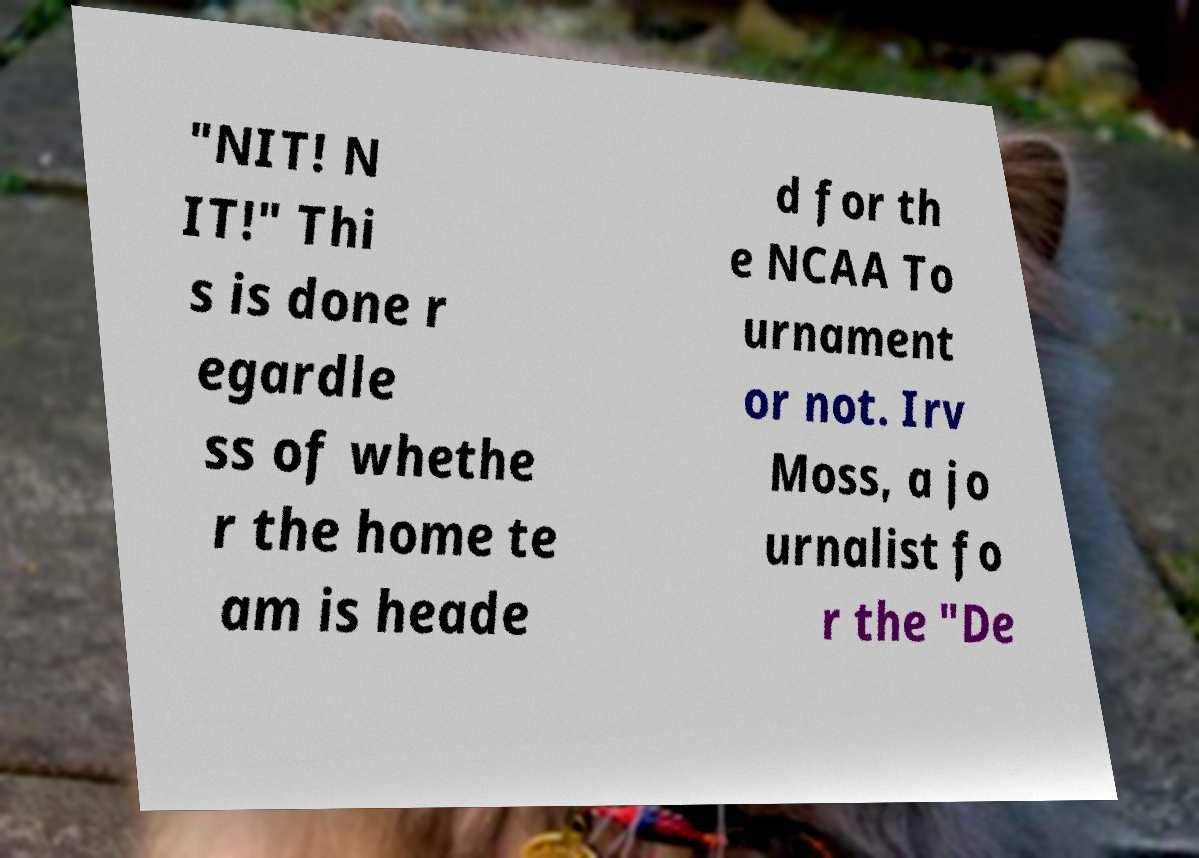For documentation purposes, I need the text within this image transcribed. Could you provide that? "NIT! N IT!" Thi s is done r egardle ss of whethe r the home te am is heade d for th e NCAA To urnament or not. Irv Moss, a jo urnalist fo r the "De 